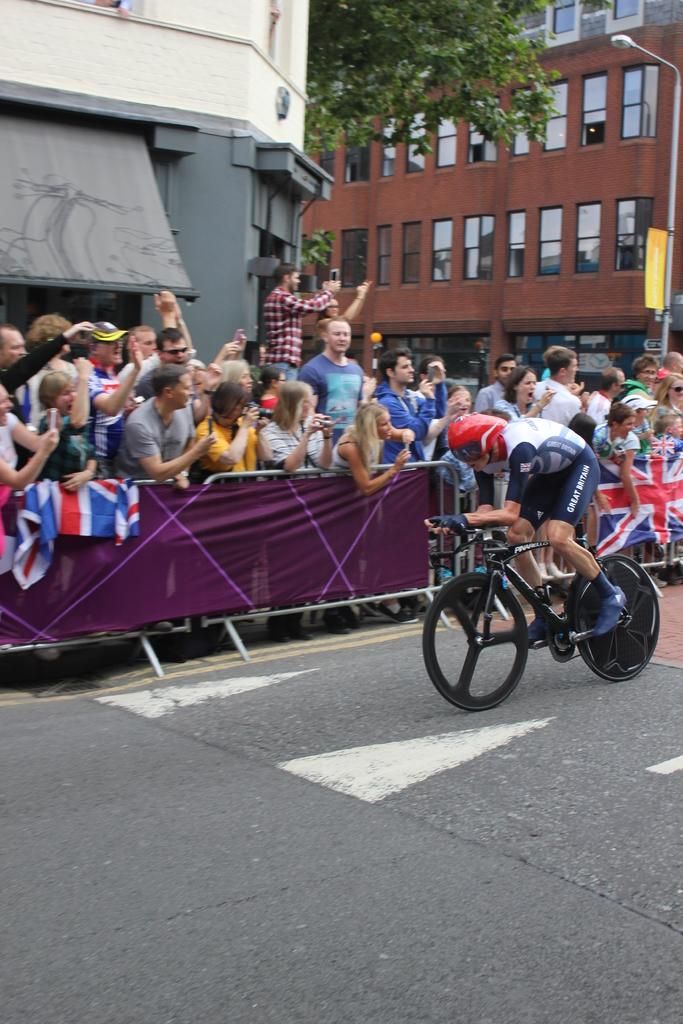What is the person in the image doing? The person is riding a bicycle on the road. What can be seen in the image besides the person on the bicycle? There are flags, a group of people, buildings, a pole, a board, and trees visible in the background. Can you describe the surroundings of the person on the bicycle? The person is riding on the road, with buildings, a pole, a board, and trees in the background. What type of haircut is the person on the bicycle getting? There is no indication of a haircut in the image. 